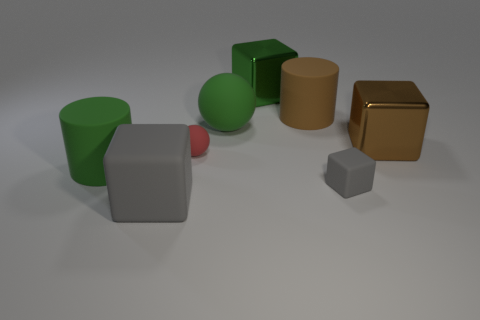Subtract all yellow cylinders. How many gray cubes are left? 2 Subtract all big rubber cubes. How many cubes are left? 3 Subtract all green cubes. How many cubes are left? 3 Subtract 2 blocks. How many blocks are left? 2 Add 1 small red cubes. How many objects exist? 9 Subtract all blue cubes. Subtract all cyan cylinders. How many cubes are left? 4 Subtract all spheres. How many objects are left? 6 Subtract all small gray rubber cubes. Subtract all green rubber balls. How many objects are left? 6 Add 3 gray things. How many gray things are left? 5 Add 6 large yellow rubber balls. How many large yellow rubber balls exist? 6 